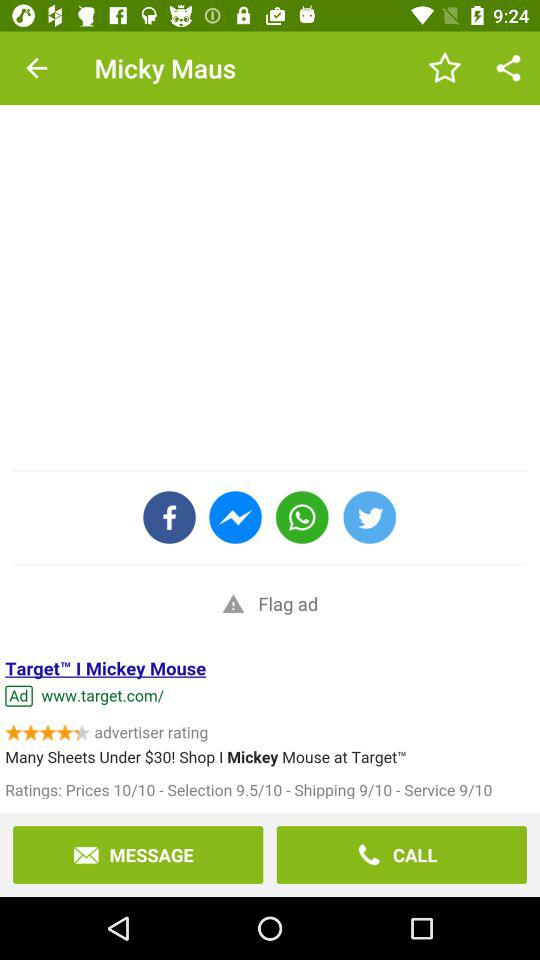What's the rating for shipping? The rating for shipping is 9. 